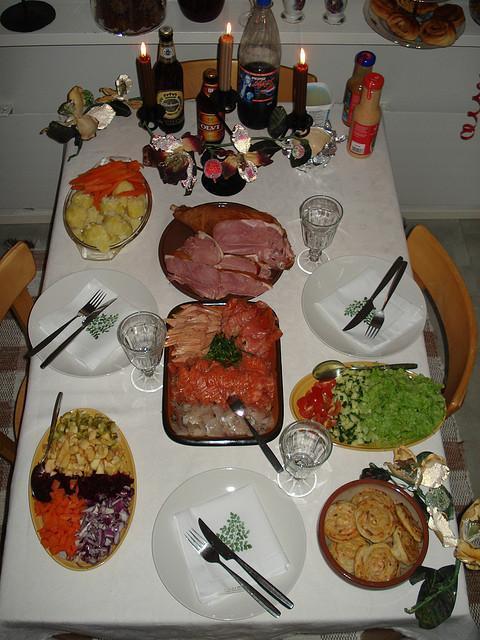How many bowls are in the photo?
Give a very brief answer. 3. How many bottles can you see?
Give a very brief answer. 3. How many carrots are there?
Give a very brief answer. 2. How many chairs are there?
Give a very brief answer. 2. How many wine glasses can be seen?
Give a very brief answer. 3. How many people are wearing glasses?
Give a very brief answer. 0. 